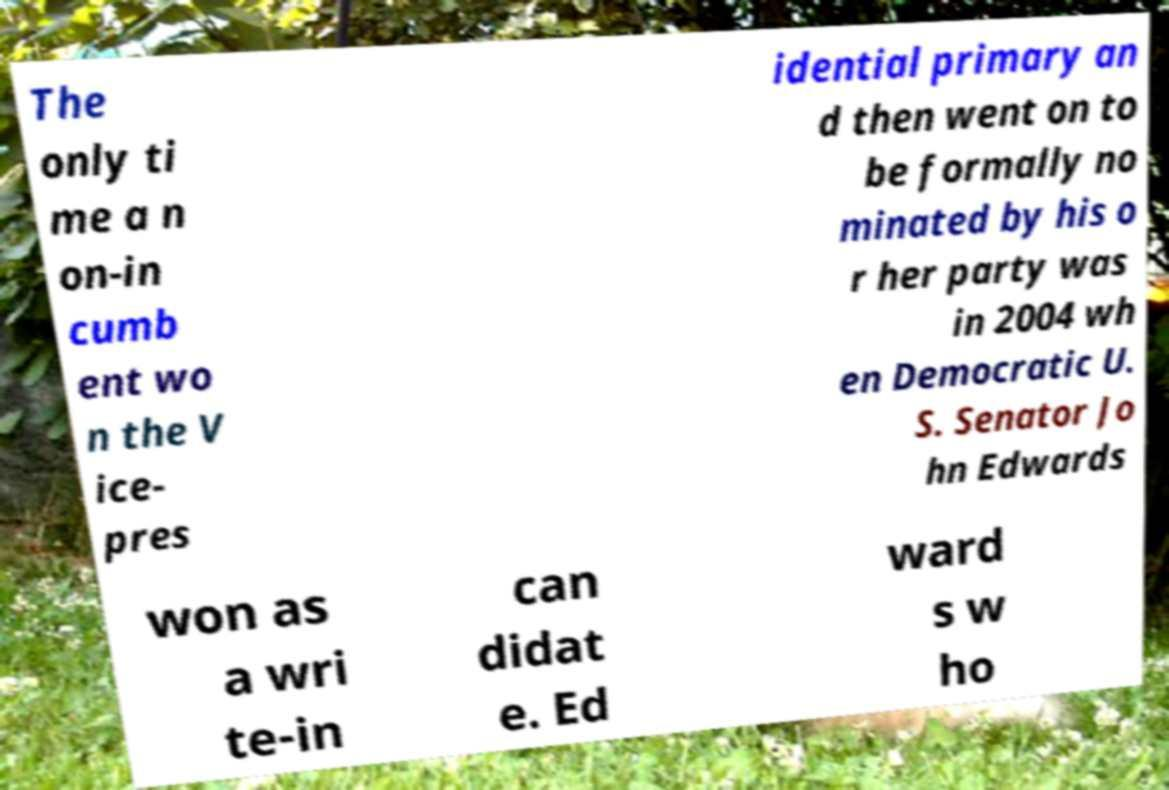Can you read and provide the text displayed in the image?This photo seems to have some interesting text. Can you extract and type it out for me? The only ti me a n on-in cumb ent wo n the V ice- pres idential primary an d then went on to be formally no minated by his o r her party was in 2004 wh en Democratic U. S. Senator Jo hn Edwards won as a wri te-in can didat e. Ed ward s w ho 